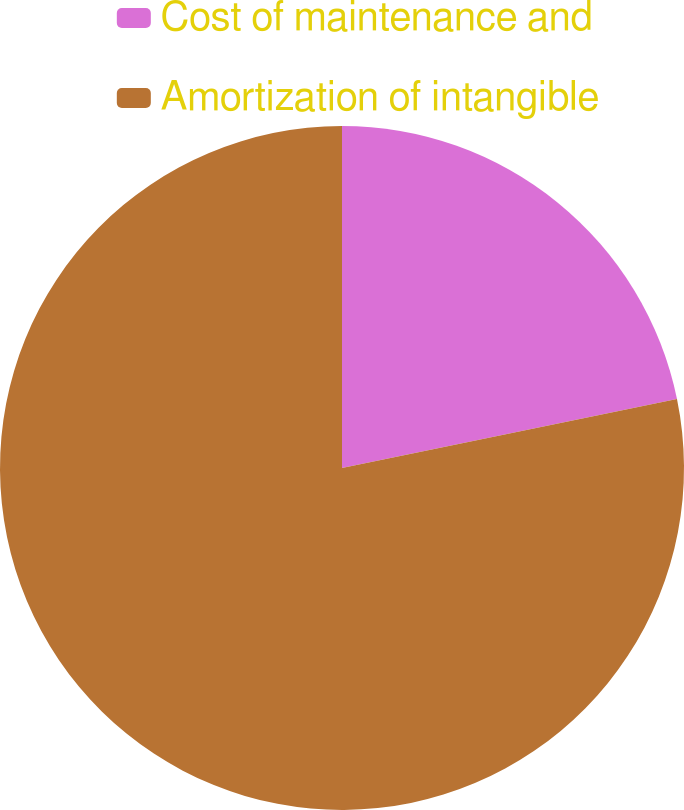Convert chart to OTSL. <chart><loc_0><loc_0><loc_500><loc_500><pie_chart><fcel>Cost of maintenance and<fcel>Amortization of intangible<nl><fcel>21.77%<fcel>78.23%<nl></chart> 